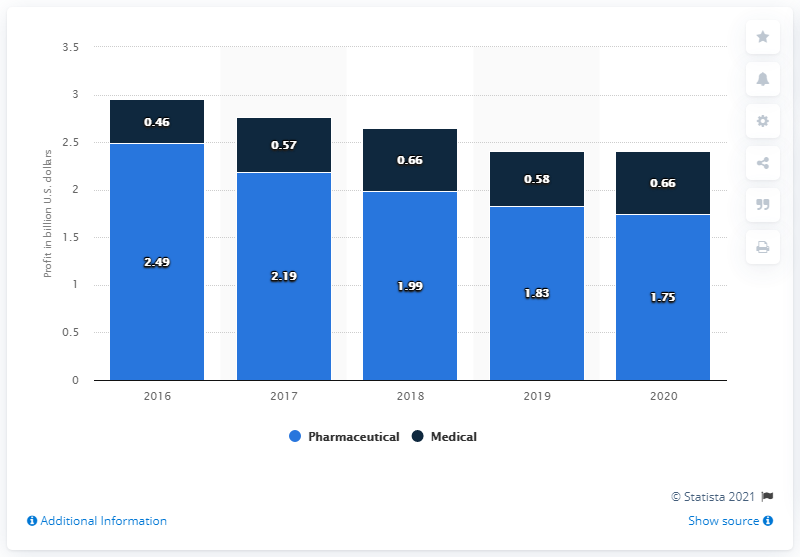Draw attention to some important aspects in this diagram. The profit from the pharmaceutical segment of Cardinal Health in 2020 was $1.75 million. 